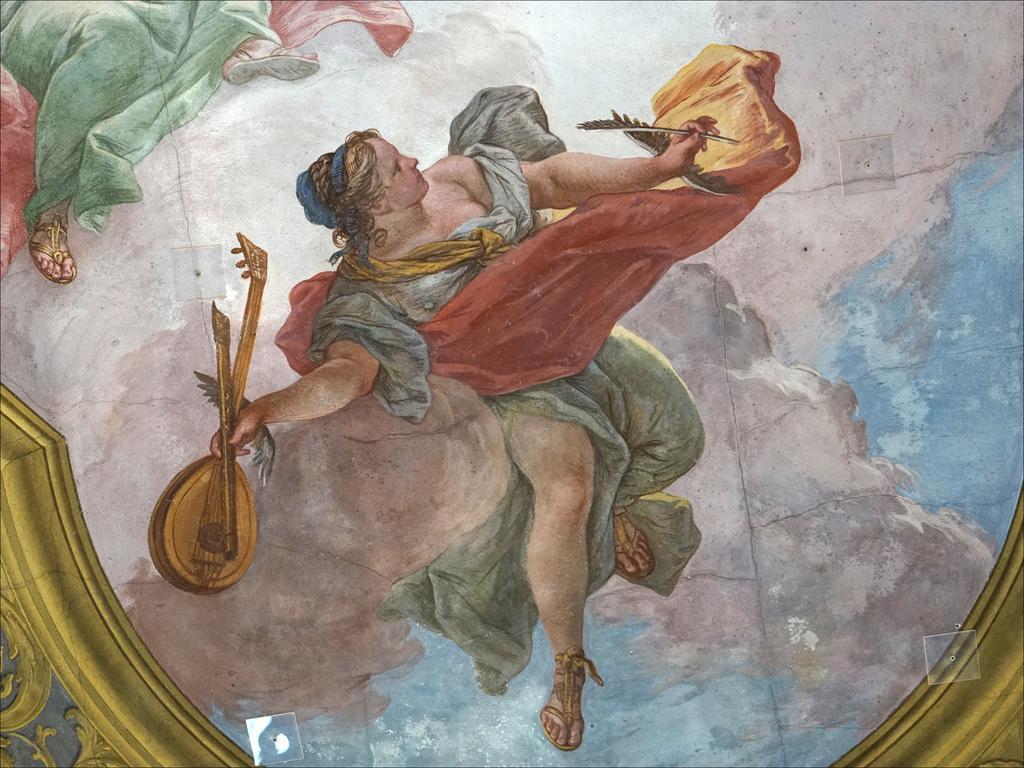Describe this image in one or two sentences. This image is a painting. In this painting we can see a person holding a musical instrument. At the top there is another person. 